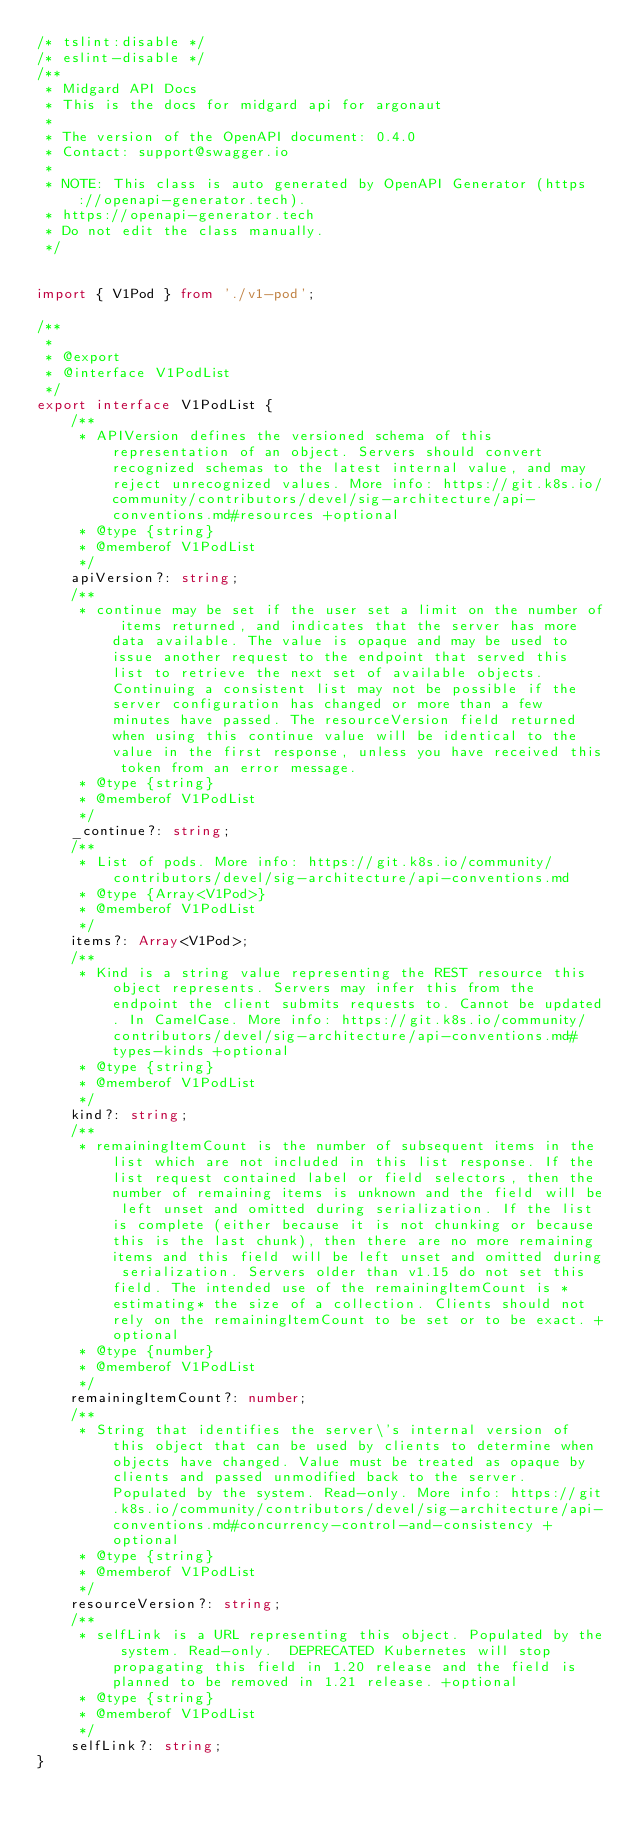<code> <loc_0><loc_0><loc_500><loc_500><_TypeScript_>/* tslint:disable */
/* eslint-disable */
/**
 * Midgard API Docs
 * This is the docs for midgard api for argonaut
 *
 * The version of the OpenAPI document: 0.4.0
 * Contact: support@swagger.io
 *
 * NOTE: This class is auto generated by OpenAPI Generator (https://openapi-generator.tech).
 * https://openapi-generator.tech
 * Do not edit the class manually.
 */


import { V1Pod } from './v1-pod';

/**
 * 
 * @export
 * @interface V1PodList
 */
export interface V1PodList {
    /**
     * APIVersion defines the versioned schema of this representation of an object. Servers should convert recognized schemas to the latest internal value, and may reject unrecognized values. More info: https://git.k8s.io/community/contributors/devel/sig-architecture/api-conventions.md#resources +optional
     * @type {string}
     * @memberof V1PodList
     */
    apiVersion?: string;
    /**
     * continue may be set if the user set a limit on the number of items returned, and indicates that the server has more data available. The value is opaque and may be used to issue another request to the endpoint that served this list to retrieve the next set of available objects. Continuing a consistent list may not be possible if the server configuration has changed or more than a few minutes have passed. The resourceVersion field returned when using this continue value will be identical to the value in the first response, unless you have received this token from an error message.
     * @type {string}
     * @memberof V1PodList
     */
    _continue?: string;
    /**
     * List of pods. More info: https://git.k8s.io/community/contributors/devel/sig-architecture/api-conventions.md
     * @type {Array<V1Pod>}
     * @memberof V1PodList
     */
    items?: Array<V1Pod>;
    /**
     * Kind is a string value representing the REST resource this object represents. Servers may infer this from the endpoint the client submits requests to. Cannot be updated. In CamelCase. More info: https://git.k8s.io/community/contributors/devel/sig-architecture/api-conventions.md#types-kinds +optional
     * @type {string}
     * @memberof V1PodList
     */
    kind?: string;
    /**
     * remainingItemCount is the number of subsequent items in the list which are not included in this list response. If the list request contained label or field selectors, then the number of remaining items is unknown and the field will be left unset and omitted during serialization. If the list is complete (either because it is not chunking or because this is the last chunk), then there are no more remaining items and this field will be left unset and omitted during serialization. Servers older than v1.15 do not set this field. The intended use of the remainingItemCount is *estimating* the size of a collection. Clients should not rely on the remainingItemCount to be set or to be exact. +optional
     * @type {number}
     * @memberof V1PodList
     */
    remainingItemCount?: number;
    /**
     * String that identifies the server\'s internal version of this object that can be used by clients to determine when objects have changed. Value must be treated as opaque by clients and passed unmodified back to the server. Populated by the system. Read-only. More info: https://git.k8s.io/community/contributors/devel/sig-architecture/api-conventions.md#concurrency-control-and-consistency +optional
     * @type {string}
     * @memberof V1PodList
     */
    resourceVersion?: string;
    /**
     * selfLink is a URL representing this object. Populated by the system. Read-only.  DEPRECATED Kubernetes will stop propagating this field in 1.20 release and the field is planned to be removed in 1.21 release. +optional
     * @type {string}
     * @memberof V1PodList
     */
    selfLink?: string;
}


</code> 